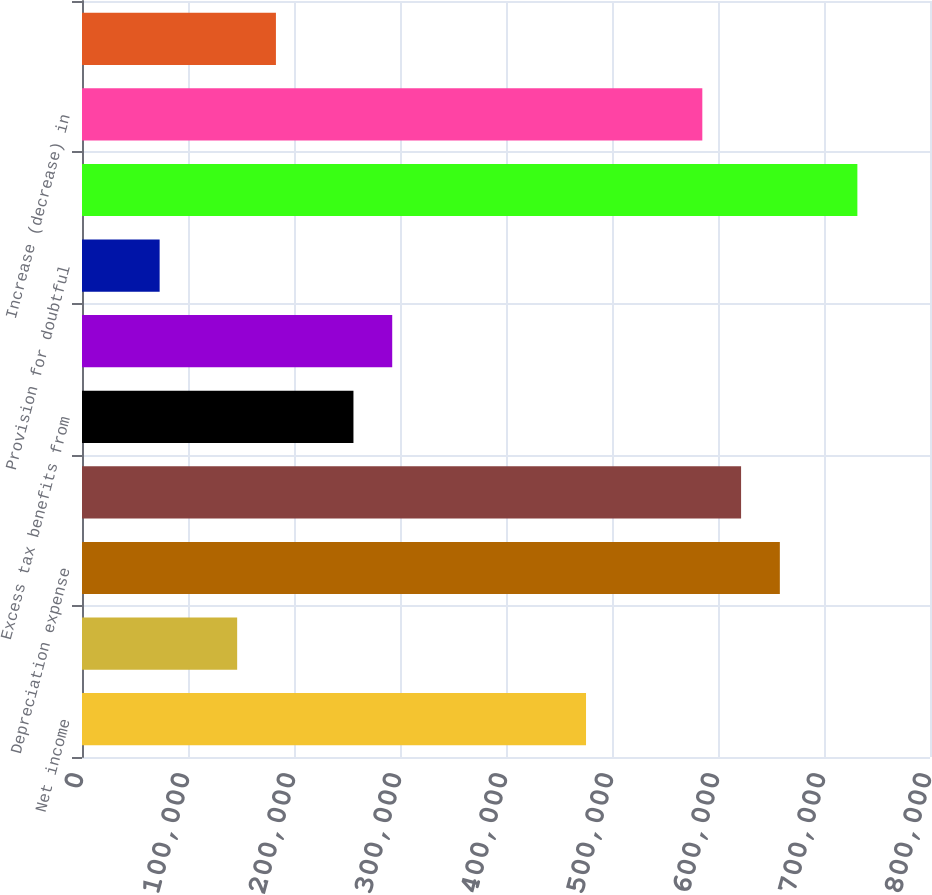Convert chart to OTSL. <chart><loc_0><loc_0><loc_500><loc_500><bar_chart><fcel>Net income<fcel>Amortization of intangible<fcel>Depreciation expense<fcel>Stock-based compensation<fcel>Excess tax benefits from<fcel>Provision for deferred income<fcel>Provision for doubtful<fcel>(Increase) decrease in<fcel>Increase (decrease) in<fcel>Increase (decrease) in income<nl><fcel>475501<fcel>146381<fcel>658345<fcel>621776<fcel>256087<fcel>292656<fcel>73242.8<fcel>731483<fcel>585207<fcel>182950<nl></chart> 